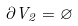Convert formula to latex. <formula><loc_0><loc_0><loc_500><loc_500>\partial V _ { 2 } = \varnothing</formula> 